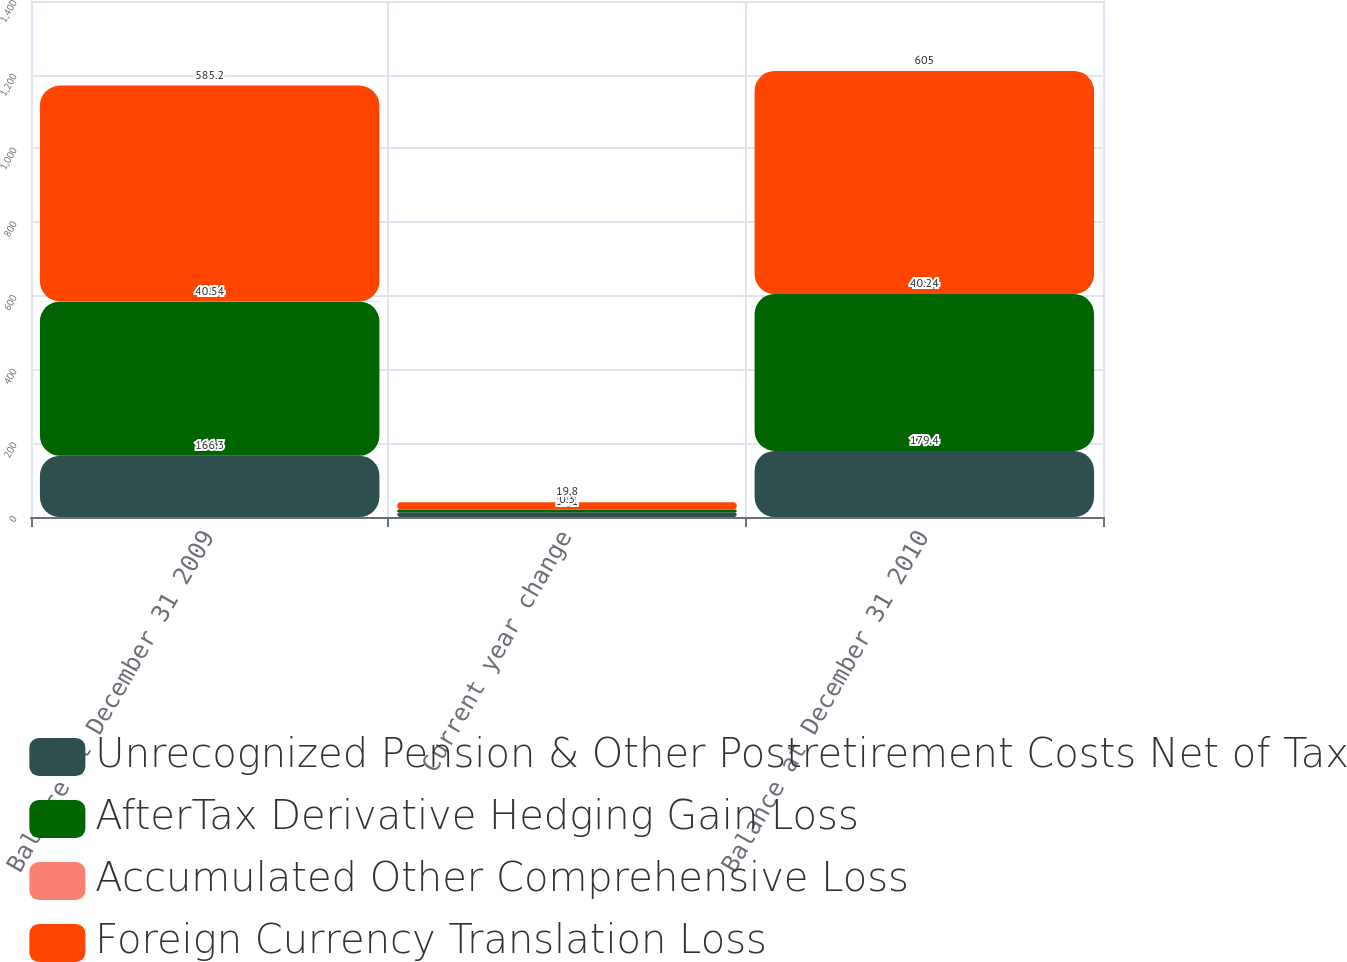Convert chart to OTSL. <chart><loc_0><loc_0><loc_500><loc_500><stacked_bar_chart><ecel><fcel>Balance at December 31 2009<fcel>Current year change<fcel>Balance at December 31 2010<nl><fcel>Unrecognized Pension & Other Postretirement Costs Net of Tax<fcel>166.3<fcel>13.1<fcel>179.4<nl><fcel>AfterTax Derivative Hedging Gain Loss<fcel>418.4<fcel>7<fcel>425.4<nl><fcel>Accumulated Other Comprehensive Loss<fcel>0.5<fcel>0.3<fcel>0.2<nl><fcel>Foreign Currency Translation Loss<fcel>585.2<fcel>19.8<fcel>605<nl></chart> 